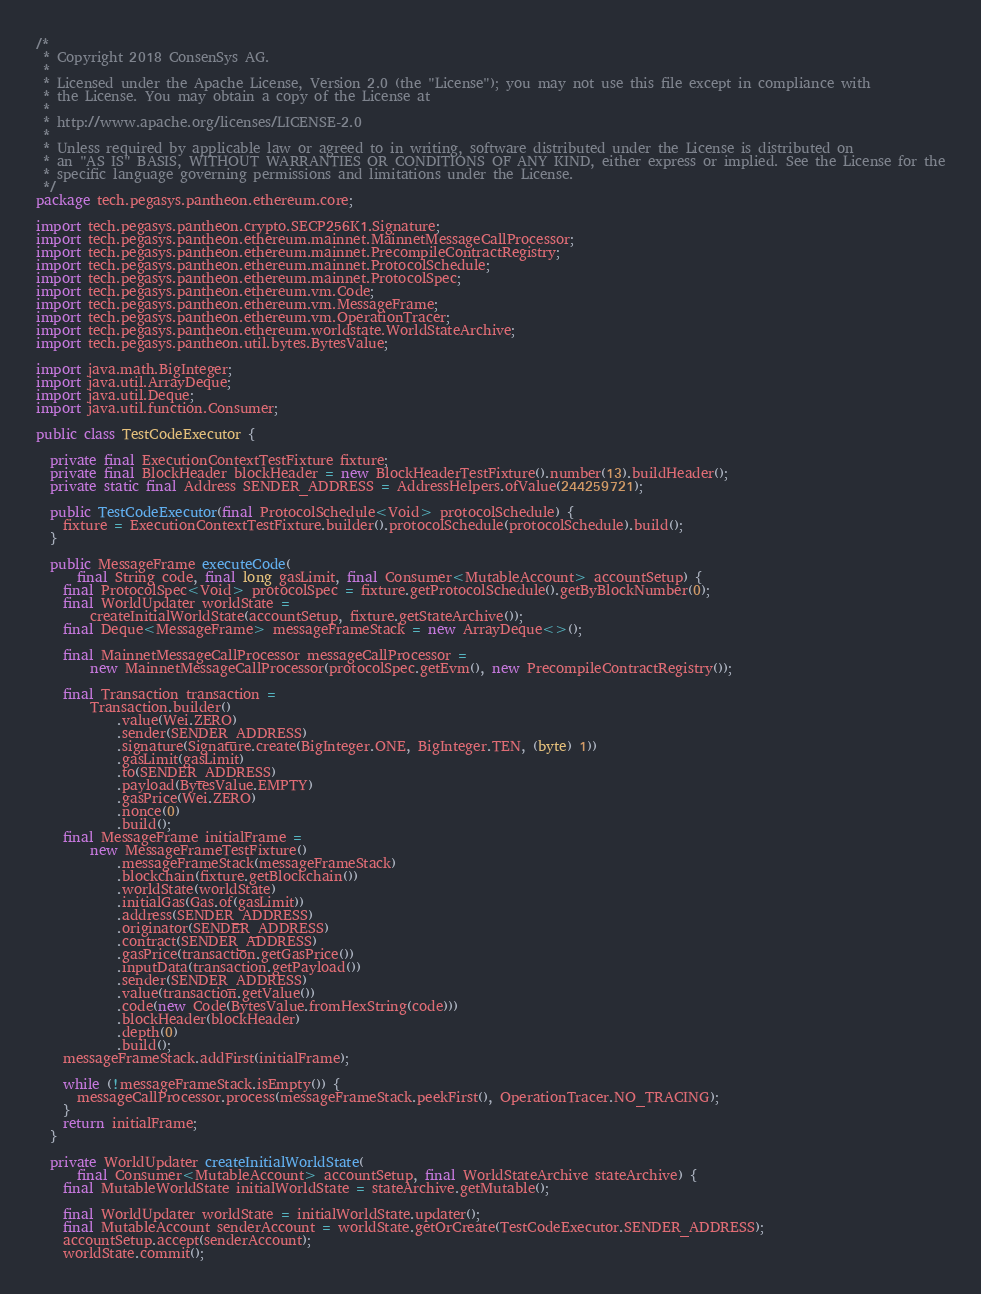<code> <loc_0><loc_0><loc_500><loc_500><_Java_>/*
 * Copyright 2018 ConsenSys AG.
 *
 * Licensed under the Apache License, Version 2.0 (the "License"); you may not use this file except in compliance with
 * the License. You may obtain a copy of the License at
 *
 * http://www.apache.org/licenses/LICENSE-2.0
 *
 * Unless required by applicable law or agreed to in writing, software distributed under the License is distributed on
 * an "AS IS" BASIS, WITHOUT WARRANTIES OR CONDITIONS OF ANY KIND, either express or implied. See the License for the
 * specific language governing permissions and limitations under the License.
 */
package tech.pegasys.pantheon.ethereum.core;

import tech.pegasys.pantheon.crypto.SECP256K1.Signature;
import tech.pegasys.pantheon.ethereum.mainnet.MainnetMessageCallProcessor;
import tech.pegasys.pantheon.ethereum.mainnet.PrecompileContractRegistry;
import tech.pegasys.pantheon.ethereum.mainnet.ProtocolSchedule;
import tech.pegasys.pantheon.ethereum.mainnet.ProtocolSpec;
import tech.pegasys.pantheon.ethereum.vm.Code;
import tech.pegasys.pantheon.ethereum.vm.MessageFrame;
import tech.pegasys.pantheon.ethereum.vm.OperationTracer;
import tech.pegasys.pantheon.ethereum.worldstate.WorldStateArchive;
import tech.pegasys.pantheon.util.bytes.BytesValue;

import java.math.BigInteger;
import java.util.ArrayDeque;
import java.util.Deque;
import java.util.function.Consumer;

public class TestCodeExecutor {

  private final ExecutionContextTestFixture fixture;
  private final BlockHeader blockHeader = new BlockHeaderTestFixture().number(13).buildHeader();
  private static final Address SENDER_ADDRESS = AddressHelpers.ofValue(244259721);

  public TestCodeExecutor(final ProtocolSchedule<Void> protocolSchedule) {
    fixture = ExecutionContextTestFixture.builder().protocolSchedule(protocolSchedule).build();
  }

  public MessageFrame executeCode(
      final String code, final long gasLimit, final Consumer<MutableAccount> accountSetup) {
    final ProtocolSpec<Void> protocolSpec = fixture.getProtocolSchedule().getByBlockNumber(0);
    final WorldUpdater worldState =
        createInitialWorldState(accountSetup, fixture.getStateArchive());
    final Deque<MessageFrame> messageFrameStack = new ArrayDeque<>();

    final MainnetMessageCallProcessor messageCallProcessor =
        new MainnetMessageCallProcessor(protocolSpec.getEvm(), new PrecompileContractRegistry());

    final Transaction transaction =
        Transaction.builder()
            .value(Wei.ZERO)
            .sender(SENDER_ADDRESS)
            .signature(Signature.create(BigInteger.ONE, BigInteger.TEN, (byte) 1))
            .gasLimit(gasLimit)
            .to(SENDER_ADDRESS)
            .payload(BytesValue.EMPTY)
            .gasPrice(Wei.ZERO)
            .nonce(0)
            .build();
    final MessageFrame initialFrame =
        new MessageFrameTestFixture()
            .messageFrameStack(messageFrameStack)
            .blockchain(fixture.getBlockchain())
            .worldState(worldState)
            .initialGas(Gas.of(gasLimit))
            .address(SENDER_ADDRESS)
            .originator(SENDER_ADDRESS)
            .contract(SENDER_ADDRESS)
            .gasPrice(transaction.getGasPrice())
            .inputData(transaction.getPayload())
            .sender(SENDER_ADDRESS)
            .value(transaction.getValue())
            .code(new Code(BytesValue.fromHexString(code)))
            .blockHeader(blockHeader)
            .depth(0)
            .build();
    messageFrameStack.addFirst(initialFrame);

    while (!messageFrameStack.isEmpty()) {
      messageCallProcessor.process(messageFrameStack.peekFirst(), OperationTracer.NO_TRACING);
    }
    return initialFrame;
  }

  private WorldUpdater createInitialWorldState(
      final Consumer<MutableAccount> accountSetup, final WorldStateArchive stateArchive) {
    final MutableWorldState initialWorldState = stateArchive.getMutable();

    final WorldUpdater worldState = initialWorldState.updater();
    final MutableAccount senderAccount = worldState.getOrCreate(TestCodeExecutor.SENDER_ADDRESS);
    accountSetup.accept(senderAccount);
    worldState.commit();</code> 